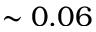<formula> <loc_0><loc_0><loc_500><loc_500>\sim 0 . 0 6</formula> 